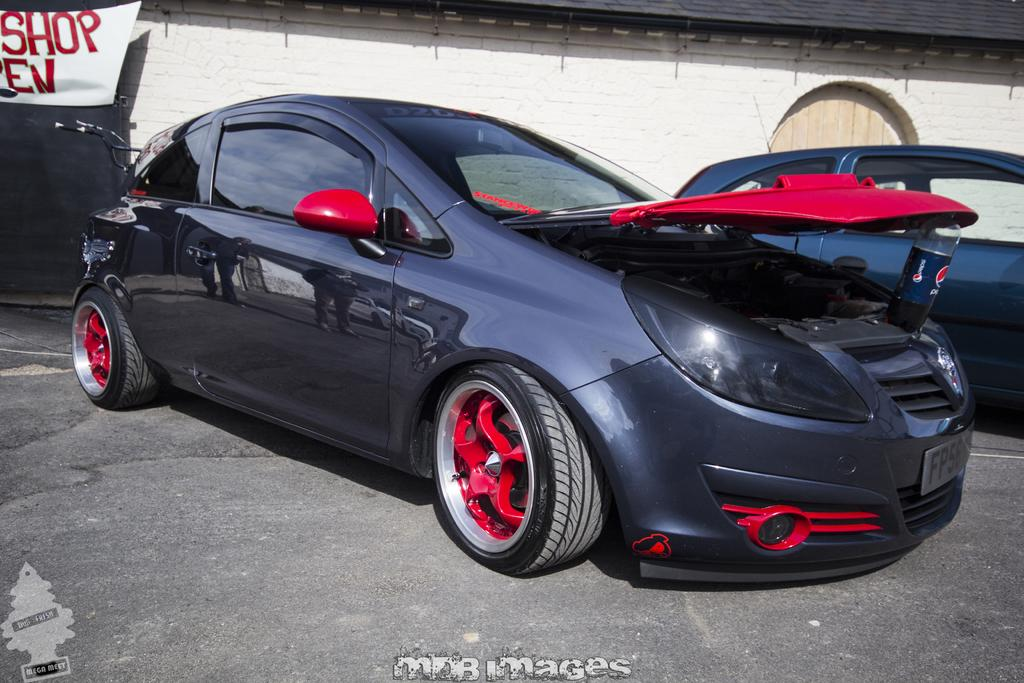How many vehicles can be seen in the image? There are two cars and a bicycle in the image. Where are the vehicles located? The vehicles are on a path in the image. What other structures are present in the image? There is a wall, a door, and a banner in the image. Are there any watermarks in the image? Yes, the image has watermarks. What type of calculator is being used by the train in the image? There is no calculator or train present in the image. What scientific experiment is being conducted in the image? There is no scientific experiment or reference to science in the image. 